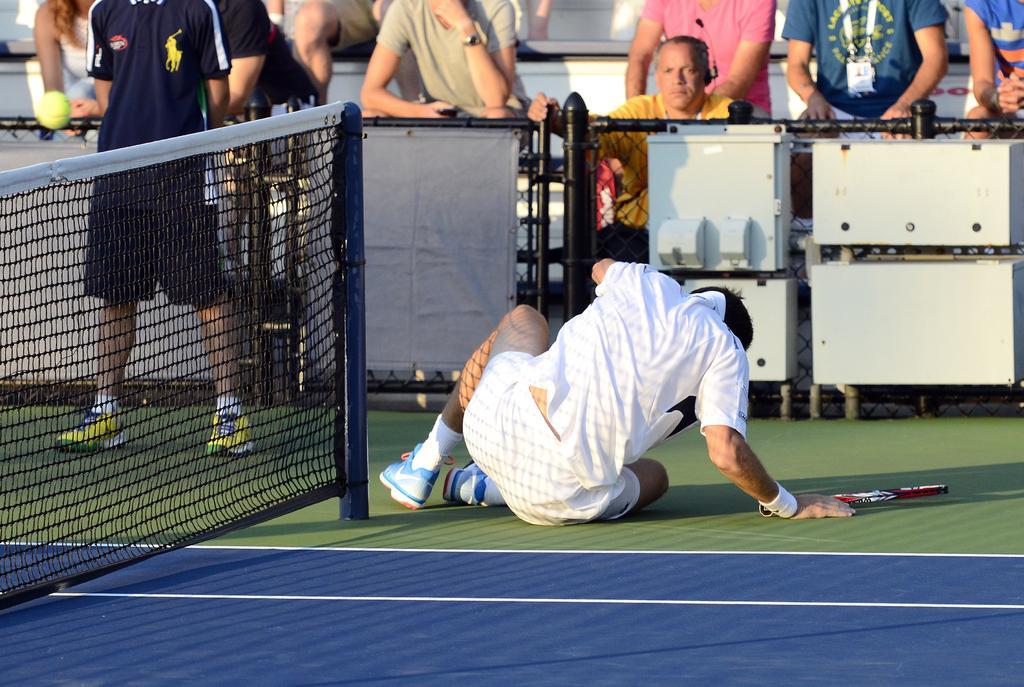Can you describe this image briefly? Here we can see a tennis player sitting on the court with racket in front of him and at the left side we can see the Tennis net and here we can see people sitting and standing in the stands 